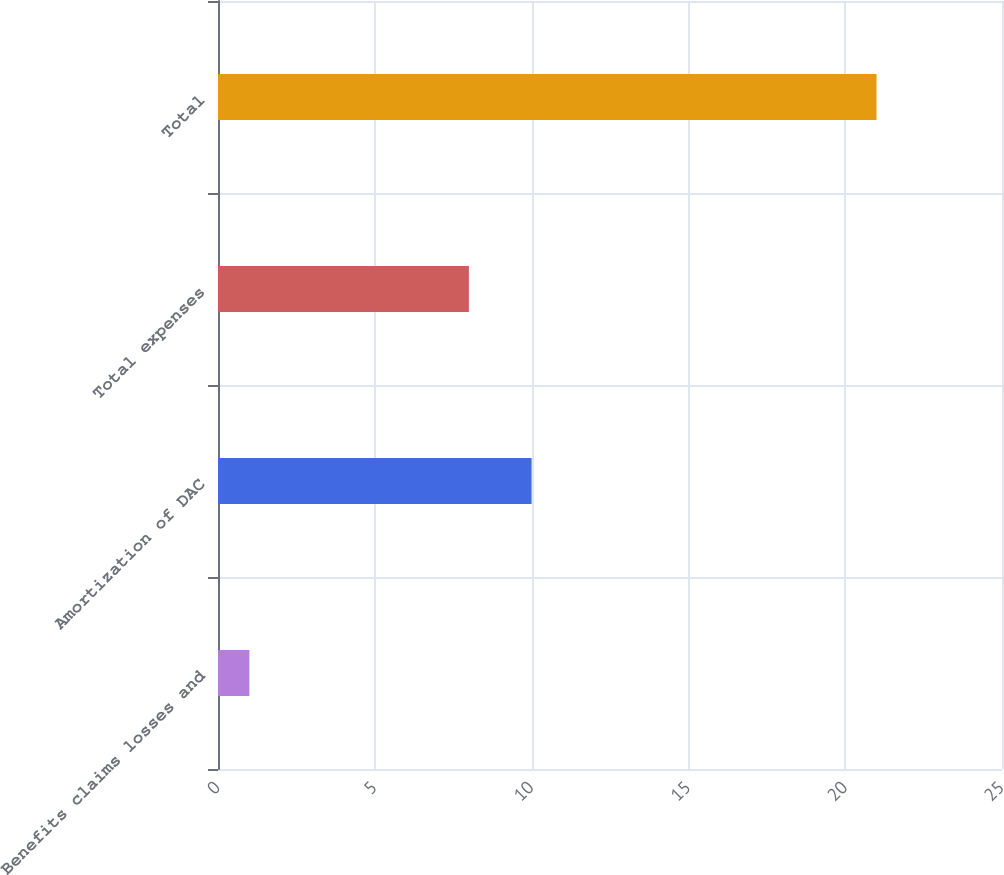Convert chart. <chart><loc_0><loc_0><loc_500><loc_500><bar_chart><fcel>Benefits claims losses and<fcel>Amortization of DAC<fcel>Total expenses<fcel>Total<nl><fcel>1<fcel>10<fcel>8<fcel>21<nl></chart> 